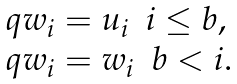<formula> <loc_0><loc_0><loc_500><loc_500>\begin{array} { l } q w _ { i } = u _ { i } \ \ i \leq b , \\ q w _ { i } = w _ { i } \ \ b < i . \end{array}</formula> 